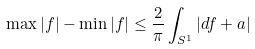<formula> <loc_0><loc_0><loc_500><loc_500>\max | f | - \min | f | \leq \frac { 2 } { \pi } \int _ { S ^ { 1 } } | d f + a |</formula> 